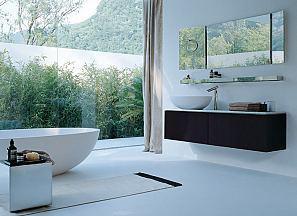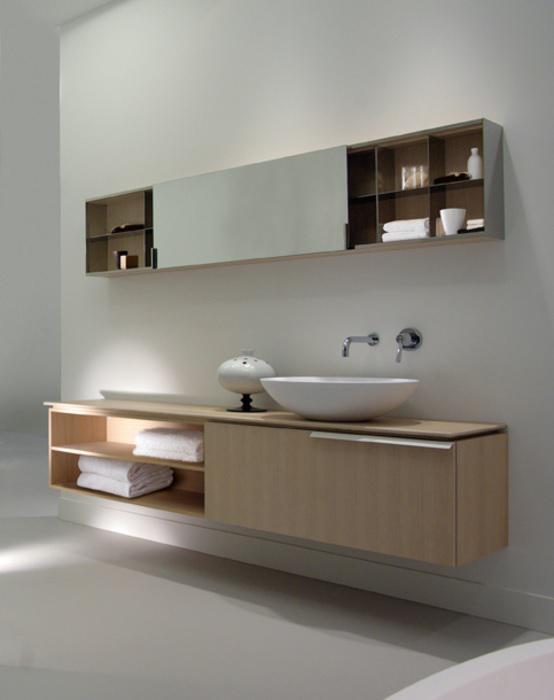The first image is the image on the left, the second image is the image on the right. For the images displayed, is the sentence "There are four white folded towels in a shelf under a sink." factually correct? Answer yes or no. Yes. The first image is the image on the left, the second image is the image on the right. Considering the images on both sides, is "There are two basins on the counter in the image on the right." valid? Answer yes or no. No. 